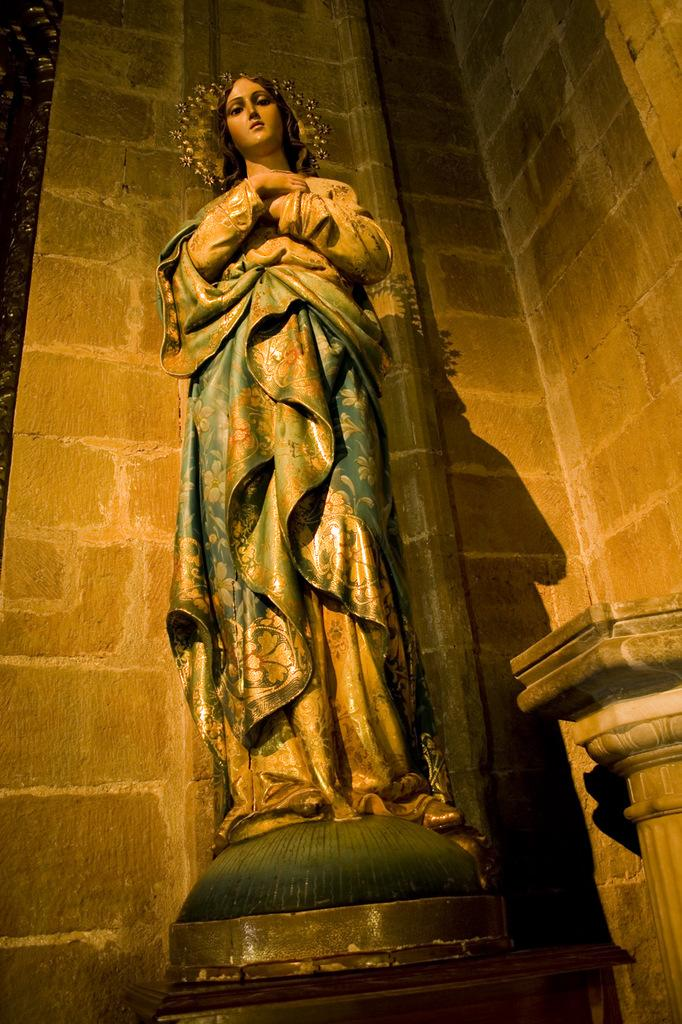What is the main subject in the image? There is a statue in the image. What else can be seen in the image besides the statue? There are walls in the image. What type of representative is standing next to the statue in the image? There is no representative present in the image; it only features a statue and walls. What part of the human body can be seen on the statue in the image? The statue in the image is not a representation of a human body, so no body parts are visible. 